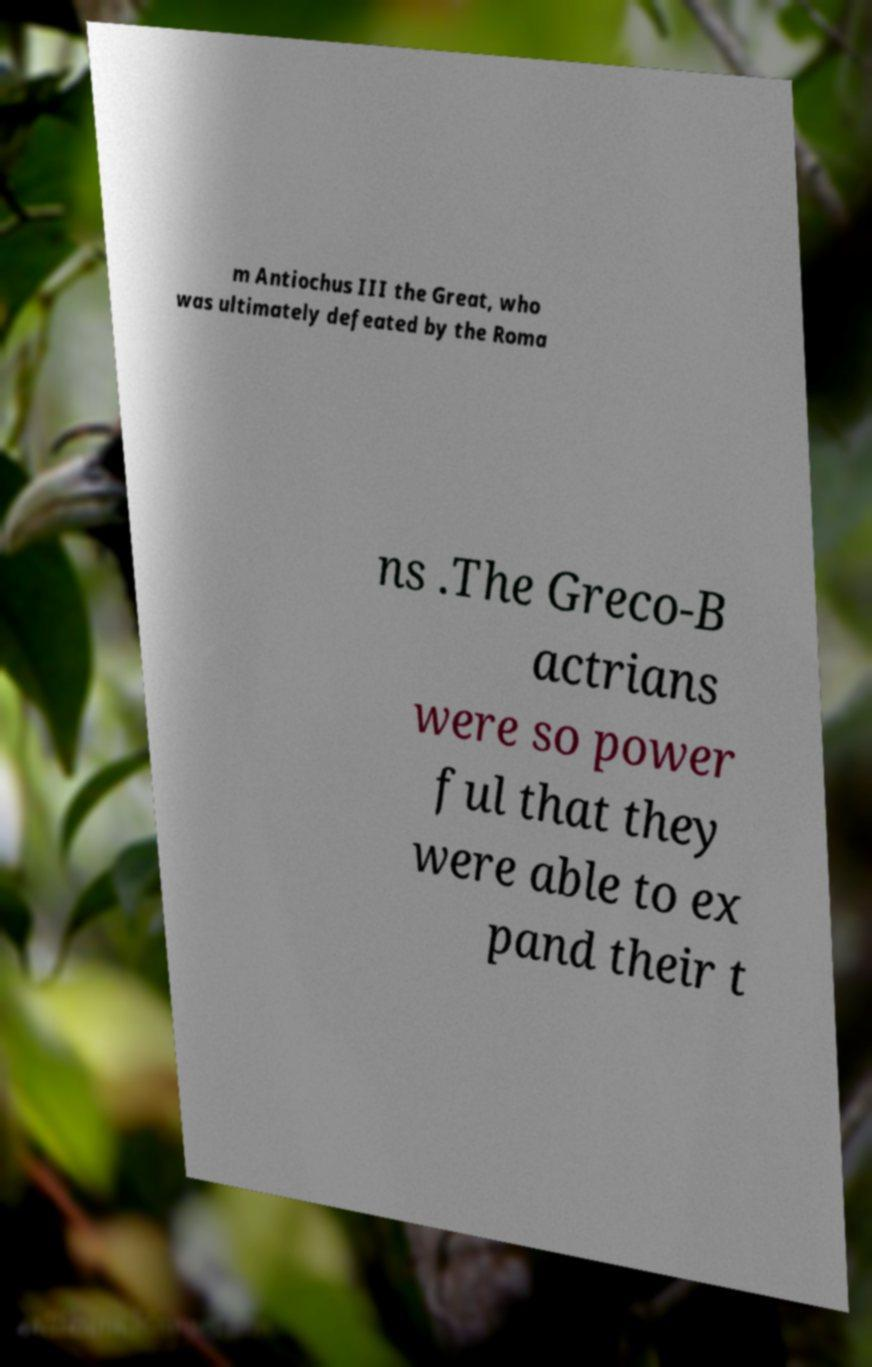I need the written content from this picture converted into text. Can you do that? m Antiochus III the Great, who was ultimately defeated by the Roma ns .The Greco-B actrians were so power ful that they were able to ex pand their t 